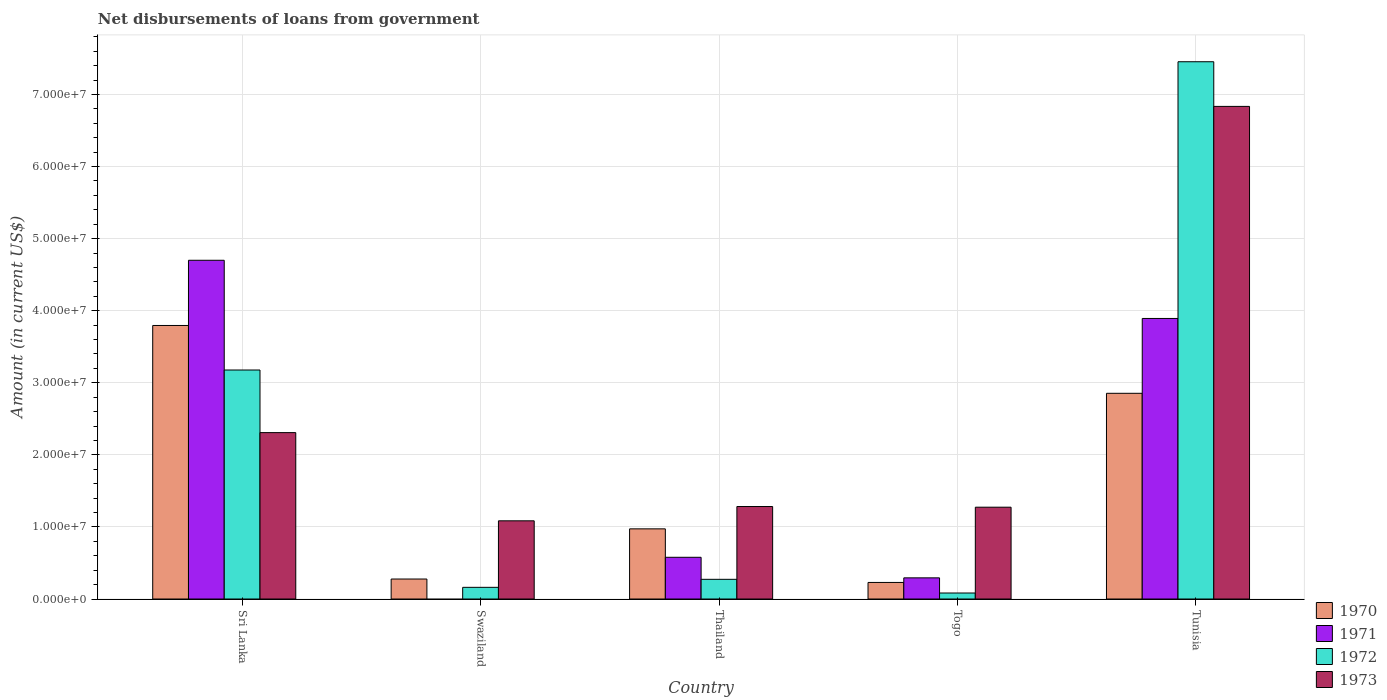How many groups of bars are there?
Make the answer very short. 5. How many bars are there on the 4th tick from the left?
Give a very brief answer. 4. How many bars are there on the 3rd tick from the right?
Keep it short and to the point. 4. What is the label of the 2nd group of bars from the left?
Offer a very short reply. Swaziland. In how many cases, is the number of bars for a given country not equal to the number of legend labels?
Give a very brief answer. 1. What is the amount of loan disbursed from government in 1972 in Swaziland?
Keep it short and to the point. 1.62e+06. Across all countries, what is the maximum amount of loan disbursed from government in 1971?
Offer a terse response. 4.70e+07. Across all countries, what is the minimum amount of loan disbursed from government in 1973?
Ensure brevity in your answer.  1.08e+07. In which country was the amount of loan disbursed from government in 1973 maximum?
Give a very brief answer. Tunisia. What is the total amount of loan disbursed from government in 1970 in the graph?
Your response must be concise. 8.13e+07. What is the difference between the amount of loan disbursed from government in 1970 in Thailand and that in Togo?
Your answer should be compact. 7.43e+06. What is the difference between the amount of loan disbursed from government in 1971 in Sri Lanka and the amount of loan disbursed from government in 1970 in Swaziland?
Provide a succinct answer. 4.42e+07. What is the average amount of loan disbursed from government in 1972 per country?
Offer a terse response. 2.23e+07. What is the difference between the amount of loan disbursed from government of/in 1970 and amount of loan disbursed from government of/in 1971 in Tunisia?
Your response must be concise. -1.04e+07. What is the ratio of the amount of loan disbursed from government in 1973 in Sri Lanka to that in Swaziland?
Keep it short and to the point. 2.13. Is the difference between the amount of loan disbursed from government in 1970 in Thailand and Togo greater than the difference between the amount of loan disbursed from government in 1971 in Thailand and Togo?
Ensure brevity in your answer.  Yes. What is the difference between the highest and the second highest amount of loan disbursed from government in 1971?
Your response must be concise. 8.07e+06. What is the difference between the highest and the lowest amount of loan disbursed from government in 1972?
Make the answer very short. 7.37e+07. In how many countries, is the amount of loan disbursed from government in 1973 greater than the average amount of loan disbursed from government in 1973 taken over all countries?
Keep it short and to the point. 1. Is it the case that in every country, the sum of the amount of loan disbursed from government in 1972 and amount of loan disbursed from government in 1970 is greater than the sum of amount of loan disbursed from government in 1971 and amount of loan disbursed from government in 1973?
Make the answer very short. No. Is it the case that in every country, the sum of the amount of loan disbursed from government in 1970 and amount of loan disbursed from government in 1971 is greater than the amount of loan disbursed from government in 1972?
Give a very brief answer. No. How many countries are there in the graph?
Offer a terse response. 5. Are the values on the major ticks of Y-axis written in scientific E-notation?
Your answer should be very brief. Yes. Does the graph contain any zero values?
Your answer should be compact. Yes. How are the legend labels stacked?
Offer a terse response. Vertical. What is the title of the graph?
Give a very brief answer. Net disbursements of loans from government. Does "2008" appear as one of the legend labels in the graph?
Make the answer very short. No. What is the label or title of the X-axis?
Your answer should be compact. Country. What is the label or title of the Y-axis?
Offer a very short reply. Amount (in current US$). What is the Amount (in current US$) in 1970 in Sri Lanka?
Give a very brief answer. 3.79e+07. What is the Amount (in current US$) of 1971 in Sri Lanka?
Your answer should be compact. 4.70e+07. What is the Amount (in current US$) in 1972 in Sri Lanka?
Keep it short and to the point. 3.18e+07. What is the Amount (in current US$) in 1973 in Sri Lanka?
Offer a terse response. 2.31e+07. What is the Amount (in current US$) of 1970 in Swaziland?
Make the answer very short. 2.77e+06. What is the Amount (in current US$) in 1972 in Swaziland?
Make the answer very short. 1.62e+06. What is the Amount (in current US$) of 1973 in Swaziland?
Ensure brevity in your answer.  1.08e+07. What is the Amount (in current US$) of 1970 in Thailand?
Keep it short and to the point. 9.73e+06. What is the Amount (in current US$) in 1971 in Thailand?
Give a very brief answer. 5.79e+06. What is the Amount (in current US$) of 1972 in Thailand?
Ensure brevity in your answer.  2.73e+06. What is the Amount (in current US$) in 1973 in Thailand?
Your answer should be very brief. 1.28e+07. What is the Amount (in current US$) in 1970 in Togo?
Keep it short and to the point. 2.30e+06. What is the Amount (in current US$) in 1971 in Togo?
Offer a terse response. 2.94e+06. What is the Amount (in current US$) of 1972 in Togo?
Give a very brief answer. 8.31e+05. What is the Amount (in current US$) of 1973 in Togo?
Your response must be concise. 1.27e+07. What is the Amount (in current US$) in 1970 in Tunisia?
Keep it short and to the point. 2.85e+07. What is the Amount (in current US$) in 1971 in Tunisia?
Your answer should be very brief. 3.89e+07. What is the Amount (in current US$) in 1972 in Tunisia?
Your answer should be very brief. 7.45e+07. What is the Amount (in current US$) in 1973 in Tunisia?
Your answer should be very brief. 6.83e+07. Across all countries, what is the maximum Amount (in current US$) in 1970?
Make the answer very short. 3.79e+07. Across all countries, what is the maximum Amount (in current US$) of 1971?
Your response must be concise. 4.70e+07. Across all countries, what is the maximum Amount (in current US$) of 1972?
Your answer should be very brief. 7.45e+07. Across all countries, what is the maximum Amount (in current US$) of 1973?
Offer a very short reply. 6.83e+07. Across all countries, what is the minimum Amount (in current US$) in 1970?
Make the answer very short. 2.30e+06. Across all countries, what is the minimum Amount (in current US$) of 1971?
Provide a short and direct response. 0. Across all countries, what is the minimum Amount (in current US$) of 1972?
Keep it short and to the point. 8.31e+05. Across all countries, what is the minimum Amount (in current US$) in 1973?
Offer a very short reply. 1.08e+07. What is the total Amount (in current US$) of 1970 in the graph?
Provide a succinct answer. 8.13e+07. What is the total Amount (in current US$) of 1971 in the graph?
Provide a short and direct response. 9.46e+07. What is the total Amount (in current US$) in 1972 in the graph?
Ensure brevity in your answer.  1.11e+08. What is the total Amount (in current US$) in 1973 in the graph?
Your answer should be compact. 1.28e+08. What is the difference between the Amount (in current US$) in 1970 in Sri Lanka and that in Swaziland?
Give a very brief answer. 3.52e+07. What is the difference between the Amount (in current US$) in 1972 in Sri Lanka and that in Swaziland?
Offer a terse response. 3.02e+07. What is the difference between the Amount (in current US$) in 1973 in Sri Lanka and that in Swaziland?
Offer a terse response. 1.22e+07. What is the difference between the Amount (in current US$) in 1970 in Sri Lanka and that in Thailand?
Your answer should be compact. 2.82e+07. What is the difference between the Amount (in current US$) in 1971 in Sri Lanka and that in Thailand?
Ensure brevity in your answer.  4.12e+07. What is the difference between the Amount (in current US$) of 1972 in Sri Lanka and that in Thailand?
Your answer should be very brief. 2.90e+07. What is the difference between the Amount (in current US$) in 1973 in Sri Lanka and that in Thailand?
Give a very brief answer. 1.03e+07. What is the difference between the Amount (in current US$) in 1970 in Sri Lanka and that in Togo?
Provide a short and direct response. 3.56e+07. What is the difference between the Amount (in current US$) in 1971 in Sri Lanka and that in Togo?
Ensure brevity in your answer.  4.41e+07. What is the difference between the Amount (in current US$) in 1972 in Sri Lanka and that in Togo?
Your answer should be very brief. 3.09e+07. What is the difference between the Amount (in current US$) in 1973 in Sri Lanka and that in Togo?
Ensure brevity in your answer.  1.03e+07. What is the difference between the Amount (in current US$) of 1970 in Sri Lanka and that in Tunisia?
Your answer should be very brief. 9.41e+06. What is the difference between the Amount (in current US$) in 1971 in Sri Lanka and that in Tunisia?
Offer a very short reply. 8.07e+06. What is the difference between the Amount (in current US$) in 1972 in Sri Lanka and that in Tunisia?
Offer a very short reply. -4.28e+07. What is the difference between the Amount (in current US$) of 1973 in Sri Lanka and that in Tunisia?
Your answer should be very brief. -4.53e+07. What is the difference between the Amount (in current US$) in 1970 in Swaziland and that in Thailand?
Provide a succinct answer. -6.96e+06. What is the difference between the Amount (in current US$) of 1972 in Swaziland and that in Thailand?
Your answer should be very brief. -1.11e+06. What is the difference between the Amount (in current US$) in 1973 in Swaziland and that in Thailand?
Offer a terse response. -1.98e+06. What is the difference between the Amount (in current US$) in 1970 in Swaziland and that in Togo?
Offer a very short reply. 4.73e+05. What is the difference between the Amount (in current US$) in 1972 in Swaziland and that in Togo?
Your response must be concise. 7.87e+05. What is the difference between the Amount (in current US$) in 1973 in Swaziland and that in Togo?
Provide a short and direct response. -1.89e+06. What is the difference between the Amount (in current US$) in 1970 in Swaziland and that in Tunisia?
Offer a very short reply. -2.58e+07. What is the difference between the Amount (in current US$) of 1972 in Swaziland and that in Tunisia?
Your answer should be very brief. -7.29e+07. What is the difference between the Amount (in current US$) of 1973 in Swaziland and that in Tunisia?
Offer a terse response. -5.75e+07. What is the difference between the Amount (in current US$) of 1970 in Thailand and that in Togo?
Provide a succinct answer. 7.43e+06. What is the difference between the Amount (in current US$) in 1971 in Thailand and that in Togo?
Offer a terse response. 2.85e+06. What is the difference between the Amount (in current US$) in 1972 in Thailand and that in Togo?
Your answer should be compact. 1.90e+06. What is the difference between the Amount (in current US$) of 1973 in Thailand and that in Togo?
Your response must be concise. 9.30e+04. What is the difference between the Amount (in current US$) in 1970 in Thailand and that in Tunisia?
Your answer should be compact. -1.88e+07. What is the difference between the Amount (in current US$) in 1971 in Thailand and that in Tunisia?
Offer a terse response. -3.31e+07. What is the difference between the Amount (in current US$) of 1972 in Thailand and that in Tunisia?
Make the answer very short. -7.18e+07. What is the difference between the Amount (in current US$) in 1973 in Thailand and that in Tunisia?
Ensure brevity in your answer.  -5.55e+07. What is the difference between the Amount (in current US$) in 1970 in Togo and that in Tunisia?
Ensure brevity in your answer.  -2.62e+07. What is the difference between the Amount (in current US$) of 1971 in Togo and that in Tunisia?
Your answer should be compact. -3.60e+07. What is the difference between the Amount (in current US$) in 1972 in Togo and that in Tunisia?
Keep it short and to the point. -7.37e+07. What is the difference between the Amount (in current US$) of 1973 in Togo and that in Tunisia?
Your answer should be very brief. -5.56e+07. What is the difference between the Amount (in current US$) in 1970 in Sri Lanka and the Amount (in current US$) in 1972 in Swaziland?
Provide a short and direct response. 3.63e+07. What is the difference between the Amount (in current US$) of 1970 in Sri Lanka and the Amount (in current US$) of 1973 in Swaziland?
Give a very brief answer. 2.71e+07. What is the difference between the Amount (in current US$) in 1971 in Sri Lanka and the Amount (in current US$) in 1972 in Swaziland?
Your response must be concise. 4.54e+07. What is the difference between the Amount (in current US$) of 1971 in Sri Lanka and the Amount (in current US$) of 1973 in Swaziland?
Your answer should be very brief. 3.61e+07. What is the difference between the Amount (in current US$) in 1972 in Sri Lanka and the Amount (in current US$) in 1973 in Swaziland?
Your response must be concise. 2.09e+07. What is the difference between the Amount (in current US$) of 1970 in Sri Lanka and the Amount (in current US$) of 1971 in Thailand?
Your response must be concise. 3.22e+07. What is the difference between the Amount (in current US$) of 1970 in Sri Lanka and the Amount (in current US$) of 1972 in Thailand?
Offer a very short reply. 3.52e+07. What is the difference between the Amount (in current US$) in 1970 in Sri Lanka and the Amount (in current US$) in 1973 in Thailand?
Offer a terse response. 2.51e+07. What is the difference between the Amount (in current US$) of 1971 in Sri Lanka and the Amount (in current US$) of 1972 in Thailand?
Offer a terse response. 4.43e+07. What is the difference between the Amount (in current US$) in 1971 in Sri Lanka and the Amount (in current US$) in 1973 in Thailand?
Keep it short and to the point. 3.42e+07. What is the difference between the Amount (in current US$) of 1972 in Sri Lanka and the Amount (in current US$) of 1973 in Thailand?
Keep it short and to the point. 1.89e+07. What is the difference between the Amount (in current US$) in 1970 in Sri Lanka and the Amount (in current US$) in 1971 in Togo?
Provide a succinct answer. 3.50e+07. What is the difference between the Amount (in current US$) in 1970 in Sri Lanka and the Amount (in current US$) in 1972 in Togo?
Offer a very short reply. 3.71e+07. What is the difference between the Amount (in current US$) in 1970 in Sri Lanka and the Amount (in current US$) in 1973 in Togo?
Offer a terse response. 2.52e+07. What is the difference between the Amount (in current US$) of 1971 in Sri Lanka and the Amount (in current US$) of 1972 in Togo?
Provide a succinct answer. 4.62e+07. What is the difference between the Amount (in current US$) in 1971 in Sri Lanka and the Amount (in current US$) in 1973 in Togo?
Keep it short and to the point. 3.43e+07. What is the difference between the Amount (in current US$) in 1972 in Sri Lanka and the Amount (in current US$) in 1973 in Togo?
Your response must be concise. 1.90e+07. What is the difference between the Amount (in current US$) of 1970 in Sri Lanka and the Amount (in current US$) of 1971 in Tunisia?
Your response must be concise. -9.73e+05. What is the difference between the Amount (in current US$) of 1970 in Sri Lanka and the Amount (in current US$) of 1972 in Tunisia?
Keep it short and to the point. -3.66e+07. What is the difference between the Amount (in current US$) of 1970 in Sri Lanka and the Amount (in current US$) of 1973 in Tunisia?
Offer a very short reply. -3.04e+07. What is the difference between the Amount (in current US$) in 1971 in Sri Lanka and the Amount (in current US$) in 1972 in Tunisia?
Your answer should be compact. -2.75e+07. What is the difference between the Amount (in current US$) of 1971 in Sri Lanka and the Amount (in current US$) of 1973 in Tunisia?
Your answer should be very brief. -2.13e+07. What is the difference between the Amount (in current US$) of 1972 in Sri Lanka and the Amount (in current US$) of 1973 in Tunisia?
Keep it short and to the point. -3.66e+07. What is the difference between the Amount (in current US$) in 1970 in Swaziland and the Amount (in current US$) in 1971 in Thailand?
Offer a terse response. -3.02e+06. What is the difference between the Amount (in current US$) in 1970 in Swaziland and the Amount (in current US$) in 1972 in Thailand?
Offer a very short reply. 4.10e+04. What is the difference between the Amount (in current US$) in 1970 in Swaziland and the Amount (in current US$) in 1973 in Thailand?
Ensure brevity in your answer.  -1.01e+07. What is the difference between the Amount (in current US$) in 1972 in Swaziland and the Amount (in current US$) in 1973 in Thailand?
Your answer should be compact. -1.12e+07. What is the difference between the Amount (in current US$) in 1970 in Swaziland and the Amount (in current US$) in 1971 in Togo?
Your answer should be compact. -1.64e+05. What is the difference between the Amount (in current US$) in 1970 in Swaziland and the Amount (in current US$) in 1972 in Togo?
Your answer should be compact. 1.94e+06. What is the difference between the Amount (in current US$) of 1970 in Swaziland and the Amount (in current US$) of 1973 in Togo?
Make the answer very short. -9.97e+06. What is the difference between the Amount (in current US$) in 1972 in Swaziland and the Amount (in current US$) in 1973 in Togo?
Provide a short and direct response. -1.11e+07. What is the difference between the Amount (in current US$) of 1970 in Swaziland and the Amount (in current US$) of 1971 in Tunisia?
Your answer should be very brief. -3.61e+07. What is the difference between the Amount (in current US$) in 1970 in Swaziland and the Amount (in current US$) in 1972 in Tunisia?
Provide a succinct answer. -7.18e+07. What is the difference between the Amount (in current US$) in 1970 in Swaziland and the Amount (in current US$) in 1973 in Tunisia?
Offer a very short reply. -6.56e+07. What is the difference between the Amount (in current US$) of 1972 in Swaziland and the Amount (in current US$) of 1973 in Tunisia?
Your answer should be very brief. -6.67e+07. What is the difference between the Amount (in current US$) in 1970 in Thailand and the Amount (in current US$) in 1971 in Togo?
Make the answer very short. 6.80e+06. What is the difference between the Amount (in current US$) in 1970 in Thailand and the Amount (in current US$) in 1972 in Togo?
Offer a very short reply. 8.90e+06. What is the difference between the Amount (in current US$) of 1970 in Thailand and the Amount (in current US$) of 1973 in Togo?
Provide a succinct answer. -3.00e+06. What is the difference between the Amount (in current US$) in 1971 in Thailand and the Amount (in current US$) in 1972 in Togo?
Your answer should be compact. 4.96e+06. What is the difference between the Amount (in current US$) in 1971 in Thailand and the Amount (in current US$) in 1973 in Togo?
Your answer should be compact. -6.95e+06. What is the difference between the Amount (in current US$) of 1972 in Thailand and the Amount (in current US$) of 1973 in Togo?
Make the answer very short. -1.00e+07. What is the difference between the Amount (in current US$) of 1970 in Thailand and the Amount (in current US$) of 1971 in Tunisia?
Your answer should be very brief. -2.92e+07. What is the difference between the Amount (in current US$) of 1970 in Thailand and the Amount (in current US$) of 1972 in Tunisia?
Provide a short and direct response. -6.48e+07. What is the difference between the Amount (in current US$) of 1970 in Thailand and the Amount (in current US$) of 1973 in Tunisia?
Your response must be concise. -5.86e+07. What is the difference between the Amount (in current US$) of 1971 in Thailand and the Amount (in current US$) of 1972 in Tunisia?
Make the answer very short. -6.87e+07. What is the difference between the Amount (in current US$) in 1971 in Thailand and the Amount (in current US$) in 1973 in Tunisia?
Give a very brief answer. -6.26e+07. What is the difference between the Amount (in current US$) of 1972 in Thailand and the Amount (in current US$) of 1973 in Tunisia?
Keep it short and to the point. -6.56e+07. What is the difference between the Amount (in current US$) in 1970 in Togo and the Amount (in current US$) in 1971 in Tunisia?
Provide a succinct answer. -3.66e+07. What is the difference between the Amount (in current US$) in 1970 in Togo and the Amount (in current US$) in 1972 in Tunisia?
Offer a terse response. -7.22e+07. What is the difference between the Amount (in current US$) in 1970 in Togo and the Amount (in current US$) in 1973 in Tunisia?
Keep it short and to the point. -6.60e+07. What is the difference between the Amount (in current US$) in 1971 in Togo and the Amount (in current US$) in 1972 in Tunisia?
Provide a succinct answer. -7.16e+07. What is the difference between the Amount (in current US$) of 1971 in Togo and the Amount (in current US$) of 1973 in Tunisia?
Offer a terse response. -6.54e+07. What is the difference between the Amount (in current US$) of 1972 in Togo and the Amount (in current US$) of 1973 in Tunisia?
Keep it short and to the point. -6.75e+07. What is the average Amount (in current US$) of 1970 per country?
Make the answer very short. 1.63e+07. What is the average Amount (in current US$) in 1971 per country?
Your answer should be compact. 1.89e+07. What is the average Amount (in current US$) of 1972 per country?
Keep it short and to the point. 2.23e+07. What is the average Amount (in current US$) in 1973 per country?
Offer a terse response. 2.56e+07. What is the difference between the Amount (in current US$) in 1970 and Amount (in current US$) in 1971 in Sri Lanka?
Provide a succinct answer. -9.04e+06. What is the difference between the Amount (in current US$) of 1970 and Amount (in current US$) of 1972 in Sri Lanka?
Give a very brief answer. 6.18e+06. What is the difference between the Amount (in current US$) of 1970 and Amount (in current US$) of 1973 in Sri Lanka?
Offer a terse response. 1.49e+07. What is the difference between the Amount (in current US$) in 1971 and Amount (in current US$) in 1972 in Sri Lanka?
Ensure brevity in your answer.  1.52e+07. What is the difference between the Amount (in current US$) of 1971 and Amount (in current US$) of 1973 in Sri Lanka?
Ensure brevity in your answer.  2.39e+07. What is the difference between the Amount (in current US$) of 1972 and Amount (in current US$) of 1973 in Sri Lanka?
Ensure brevity in your answer.  8.69e+06. What is the difference between the Amount (in current US$) in 1970 and Amount (in current US$) in 1972 in Swaziland?
Your answer should be compact. 1.15e+06. What is the difference between the Amount (in current US$) in 1970 and Amount (in current US$) in 1973 in Swaziland?
Ensure brevity in your answer.  -8.08e+06. What is the difference between the Amount (in current US$) of 1972 and Amount (in current US$) of 1973 in Swaziland?
Give a very brief answer. -9.23e+06. What is the difference between the Amount (in current US$) in 1970 and Amount (in current US$) in 1971 in Thailand?
Give a very brief answer. 3.94e+06. What is the difference between the Amount (in current US$) of 1970 and Amount (in current US$) of 1972 in Thailand?
Offer a terse response. 7.00e+06. What is the difference between the Amount (in current US$) in 1970 and Amount (in current US$) in 1973 in Thailand?
Your answer should be very brief. -3.10e+06. What is the difference between the Amount (in current US$) in 1971 and Amount (in current US$) in 1972 in Thailand?
Provide a succinct answer. 3.06e+06. What is the difference between the Amount (in current US$) of 1971 and Amount (in current US$) of 1973 in Thailand?
Make the answer very short. -7.04e+06. What is the difference between the Amount (in current US$) in 1972 and Amount (in current US$) in 1973 in Thailand?
Your answer should be compact. -1.01e+07. What is the difference between the Amount (in current US$) of 1970 and Amount (in current US$) of 1971 in Togo?
Your answer should be very brief. -6.37e+05. What is the difference between the Amount (in current US$) in 1970 and Amount (in current US$) in 1972 in Togo?
Provide a succinct answer. 1.47e+06. What is the difference between the Amount (in current US$) in 1970 and Amount (in current US$) in 1973 in Togo?
Provide a short and direct response. -1.04e+07. What is the difference between the Amount (in current US$) of 1971 and Amount (in current US$) of 1972 in Togo?
Keep it short and to the point. 2.10e+06. What is the difference between the Amount (in current US$) of 1971 and Amount (in current US$) of 1973 in Togo?
Keep it short and to the point. -9.80e+06. What is the difference between the Amount (in current US$) of 1972 and Amount (in current US$) of 1973 in Togo?
Provide a short and direct response. -1.19e+07. What is the difference between the Amount (in current US$) of 1970 and Amount (in current US$) of 1971 in Tunisia?
Provide a short and direct response. -1.04e+07. What is the difference between the Amount (in current US$) of 1970 and Amount (in current US$) of 1972 in Tunisia?
Your response must be concise. -4.60e+07. What is the difference between the Amount (in current US$) in 1970 and Amount (in current US$) in 1973 in Tunisia?
Offer a terse response. -3.98e+07. What is the difference between the Amount (in current US$) of 1971 and Amount (in current US$) of 1972 in Tunisia?
Offer a very short reply. -3.56e+07. What is the difference between the Amount (in current US$) in 1971 and Amount (in current US$) in 1973 in Tunisia?
Keep it short and to the point. -2.94e+07. What is the difference between the Amount (in current US$) of 1972 and Amount (in current US$) of 1973 in Tunisia?
Your answer should be compact. 6.20e+06. What is the ratio of the Amount (in current US$) of 1970 in Sri Lanka to that in Swaziland?
Offer a very short reply. 13.69. What is the ratio of the Amount (in current US$) in 1972 in Sri Lanka to that in Swaziland?
Your answer should be compact. 19.63. What is the ratio of the Amount (in current US$) of 1973 in Sri Lanka to that in Swaziland?
Offer a very short reply. 2.13. What is the ratio of the Amount (in current US$) in 1970 in Sri Lanka to that in Thailand?
Provide a short and direct response. 3.9. What is the ratio of the Amount (in current US$) in 1971 in Sri Lanka to that in Thailand?
Give a very brief answer. 8.12. What is the ratio of the Amount (in current US$) of 1972 in Sri Lanka to that in Thailand?
Provide a succinct answer. 11.64. What is the ratio of the Amount (in current US$) of 1973 in Sri Lanka to that in Thailand?
Offer a terse response. 1.8. What is the ratio of the Amount (in current US$) of 1970 in Sri Lanka to that in Togo?
Offer a very short reply. 16.51. What is the ratio of the Amount (in current US$) in 1971 in Sri Lanka to that in Togo?
Make the answer very short. 16.01. What is the ratio of the Amount (in current US$) in 1972 in Sri Lanka to that in Togo?
Your answer should be compact. 38.23. What is the ratio of the Amount (in current US$) of 1973 in Sri Lanka to that in Togo?
Your response must be concise. 1.81. What is the ratio of the Amount (in current US$) of 1970 in Sri Lanka to that in Tunisia?
Provide a succinct answer. 1.33. What is the ratio of the Amount (in current US$) in 1971 in Sri Lanka to that in Tunisia?
Offer a very short reply. 1.21. What is the ratio of the Amount (in current US$) in 1972 in Sri Lanka to that in Tunisia?
Keep it short and to the point. 0.43. What is the ratio of the Amount (in current US$) in 1973 in Sri Lanka to that in Tunisia?
Give a very brief answer. 0.34. What is the ratio of the Amount (in current US$) of 1970 in Swaziland to that in Thailand?
Ensure brevity in your answer.  0.28. What is the ratio of the Amount (in current US$) in 1972 in Swaziland to that in Thailand?
Give a very brief answer. 0.59. What is the ratio of the Amount (in current US$) in 1973 in Swaziland to that in Thailand?
Offer a very short reply. 0.85. What is the ratio of the Amount (in current US$) in 1970 in Swaziland to that in Togo?
Keep it short and to the point. 1.21. What is the ratio of the Amount (in current US$) of 1972 in Swaziland to that in Togo?
Provide a succinct answer. 1.95. What is the ratio of the Amount (in current US$) of 1973 in Swaziland to that in Togo?
Provide a succinct answer. 0.85. What is the ratio of the Amount (in current US$) of 1970 in Swaziland to that in Tunisia?
Your answer should be compact. 0.1. What is the ratio of the Amount (in current US$) in 1972 in Swaziland to that in Tunisia?
Make the answer very short. 0.02. What is the ratio of the Amount (in current US$) in 1973 in Swaziland to that in Tunisia?
Offer a very short reply. 0.16. What is the ratio of the Amount (in current US$) of 1970 in Thailand to that in Togo?
Offer a terse response. 4.24. What is the ratio of the Amount (in current US$) of 1971 in Thailand to that in Togo?
Provide a short and direct response. 1.97. What is the ratio of the Amount (in current US$) in 1972 in Thailand to that in Togo?
Your answer should be compact. 3.29. What is the ratio of the Amount (in current US$) in 1973 in Thailand to that in Togo?
Your response must be concise. 1.01. What is the ratio of the Amount (in current US$) in 1970 in Thailand to that in Tunisia?
Make the answer very short. 0.34. What is the ratio of the Amount (in current US$) in 1971 in Thailand to that in Tunisia?
Provide a short and direct response. 0.15. What is the ratio of the Amount (in current US$) in 1972 in Thailand to that in Tunisia?
Make the answer very short. 0.04. What is the ratio of the Amount (in current US$) in 1973 in Thailand to that in Tunisia?
Your answer should be compact. 0.19. What is the ratio of the Amount (in current US$) of 1970 in Togo to that in Tunisia?
Make the answer very short. 0.08. What is the ratio of the Amount (in current US$) of 1971 in Togo to that in Tunisia?
Offer a terse response. 0.08. What is the ratio of the Amount (in current US$) in 1972 in Togo to that in Tunisia?
Keep it short and to the point. 0.01. What is the ratio of the Amount (in current US$) of 1973 in Togo to that in Tunisia?
Offer a very short reply. 0.19. What is the difference between the highest and the second highest Amount (in current US$) in 1970?
Offer a very short reply. 9.41e+06. What is the difference between the highest and the second highest Amount (in current US$) of 1971?
Make the answer very short. 8.07e+06. What is the difference between the highest and the second highest Amount (in current US$) of 1972?
Offer a very short reply. 4.28e+07. What is the difference between the highest and the second highest Amount (in current US$) of 1973?
Provide a short and direct response. 4.53e+07. What is the difference between the highest and the lowest Amount (in current US$) in 1970?
Keep it short and to the point. 3.56e+07. What is the difference between the highest and the lowest Amount (in current US$) in 1971?
Your response must be concise. 4.70e+07. What is the difference between the highest and the lowest Amount (in current US$) in 1972?
Your response must be concise. 7.37e+07. What is the difference between the highest and the lowest Amount (in current US$) of 1973?
Provide a short and direct response. 5.75e+07. 